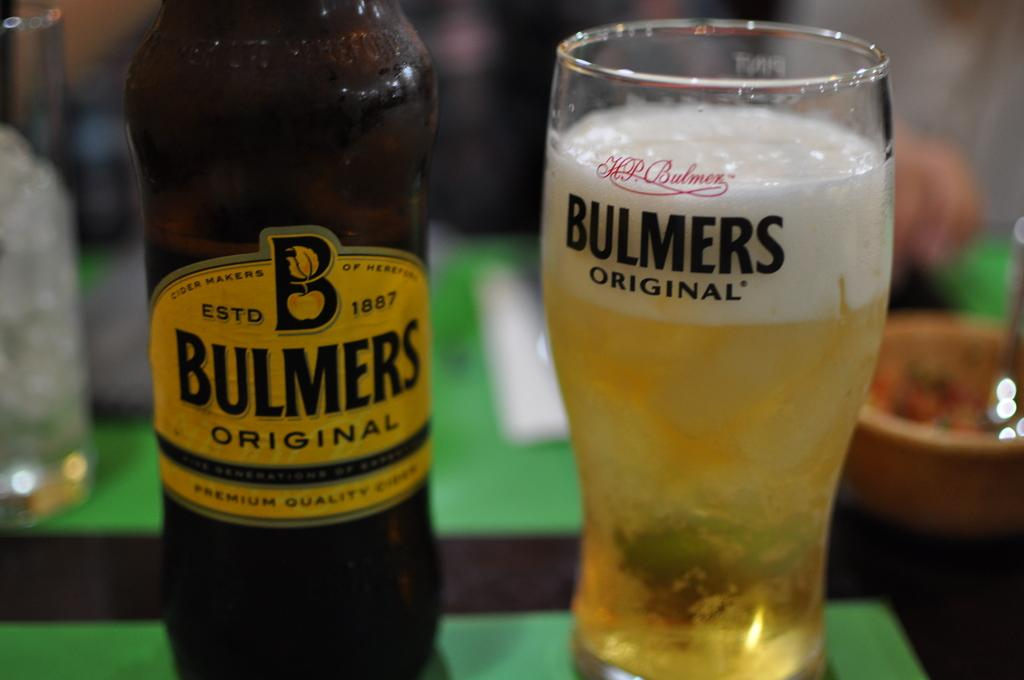<image>
Describe the image concisely. A glass full of Bulmers beer sits next to the half empty bottle 